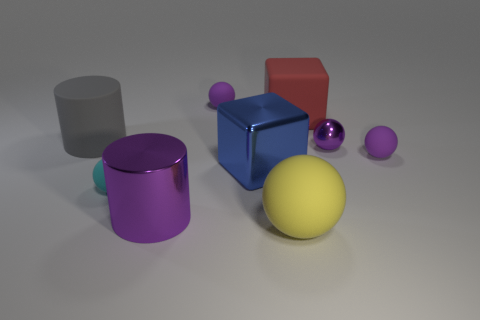There is a cube on the left side of the large rubber cube; is it the same size as the purple sphere that is to the left of the large yellow ball?
Ensure brevity in your answer.  No. How big is the shiny object that is behind the blue object?
Give a very brief answer. Small. Are there any tiny rubber things of the same color as the small metal ball?
Offer a terse response. Yes. There is a large metal cube to the right of the big metal cylinder; are there any cyan matte balls that are behind it?
Make the answer very short. No. Do the yellow object and the purple matte sphere that is to the right of the yellow matte ball have the same size?
Give a very brief answer. No. Is there a small purple object in front of the big rubber object left of the tiny purple rubber ball on the left side of the big blue metal thing?
Ensure brevity in your answer.  Yes. There is a cube behind the gray rubber thing; what material is it?
Keep it short and to the point. Rubber. Is the size of the gray object the same as the blue object?
Offer a very short reply. Yes. What color is the large rubber object that is both on the left side of the big rubber cube and behind the big yellow matte sphere?
Keep it short and to the point. Gray. There is a cyan object that is made of the same material as the large yellow sphere; what shape is it?
Provide a succinct answer. Sphere. 